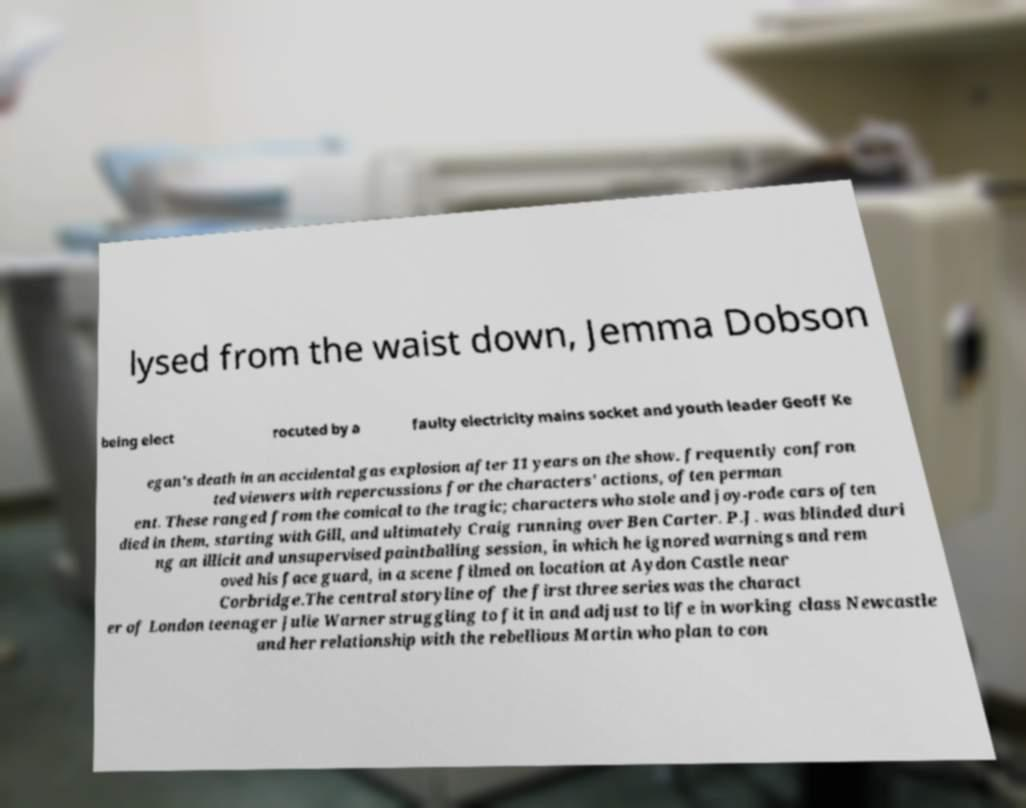Please identify and transcribe the text found in this image. lysed from the waist down, Jemma Dobson being elect rocuted by a faulty electricity mains socket and youth leader Geoff Ke egan's death in an accidental gas explosion after 11 years on the show. frequently confron ted viewers with repercussions for the characters' actions, often perman ent. These ranged from the comical to the tragic; characters who stole and joy-rode cars often died in them, starting with Gill, and ultimately Craig running over Ben Carter. P.J. was blinded duri ng an illicit and unsupervised paintballing session, in which he ignored warnings and rem oved his face guard, in a scene filmed on location at Aydon Castle near Corbridge.The central storyline of the first three series was the charact er of London teenager Julie Warner struggling to fit in and adjust to life in working class Newcastle and her relationship with the rebellious Martin who plan to con 